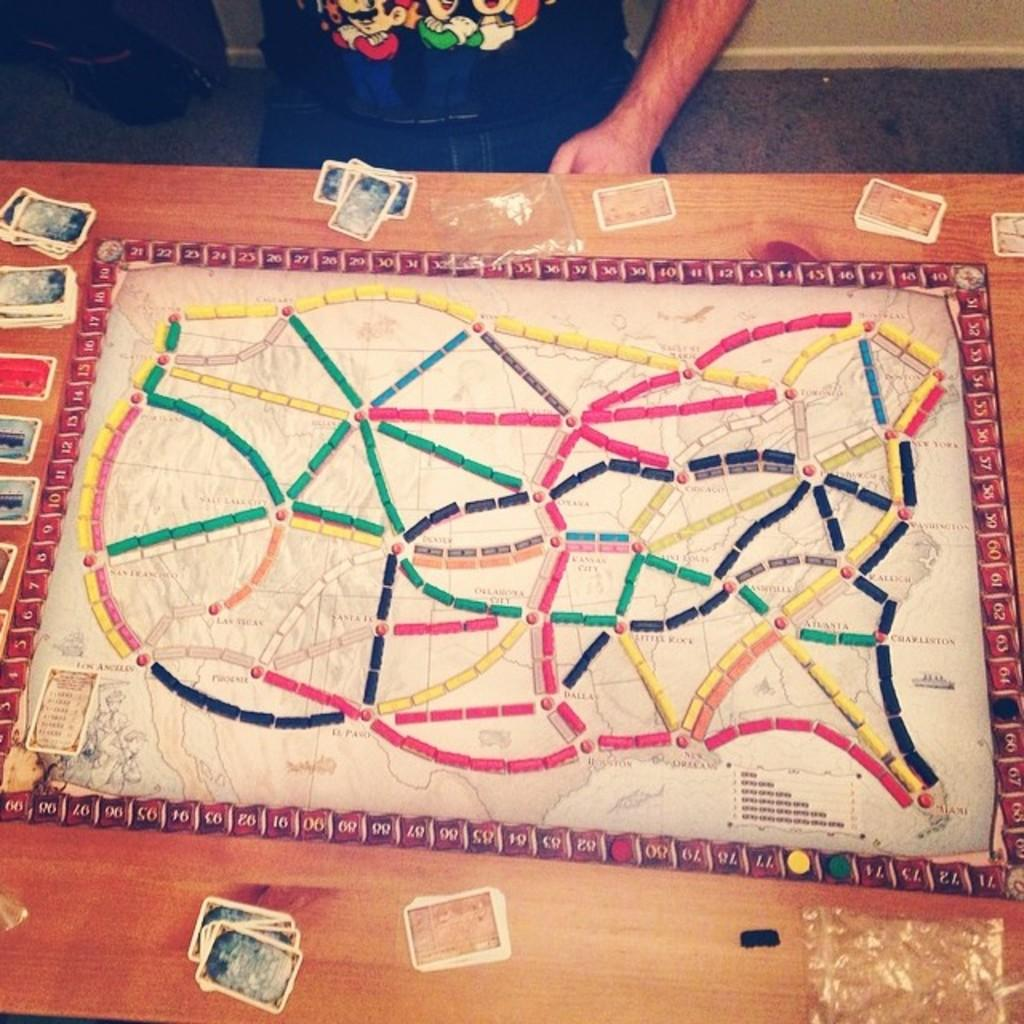What is located in the center of the image? There is a table in the middle of the image. What is on the table? There are cards on the table. Where is the man in the image? The man is sitting at the top of the image. What is behind the man? There is a wall behind the man. How many bears can be seen playing with the cards in the image? There are no bears present in the image; it features a table with cards and a man sitting at the top. 